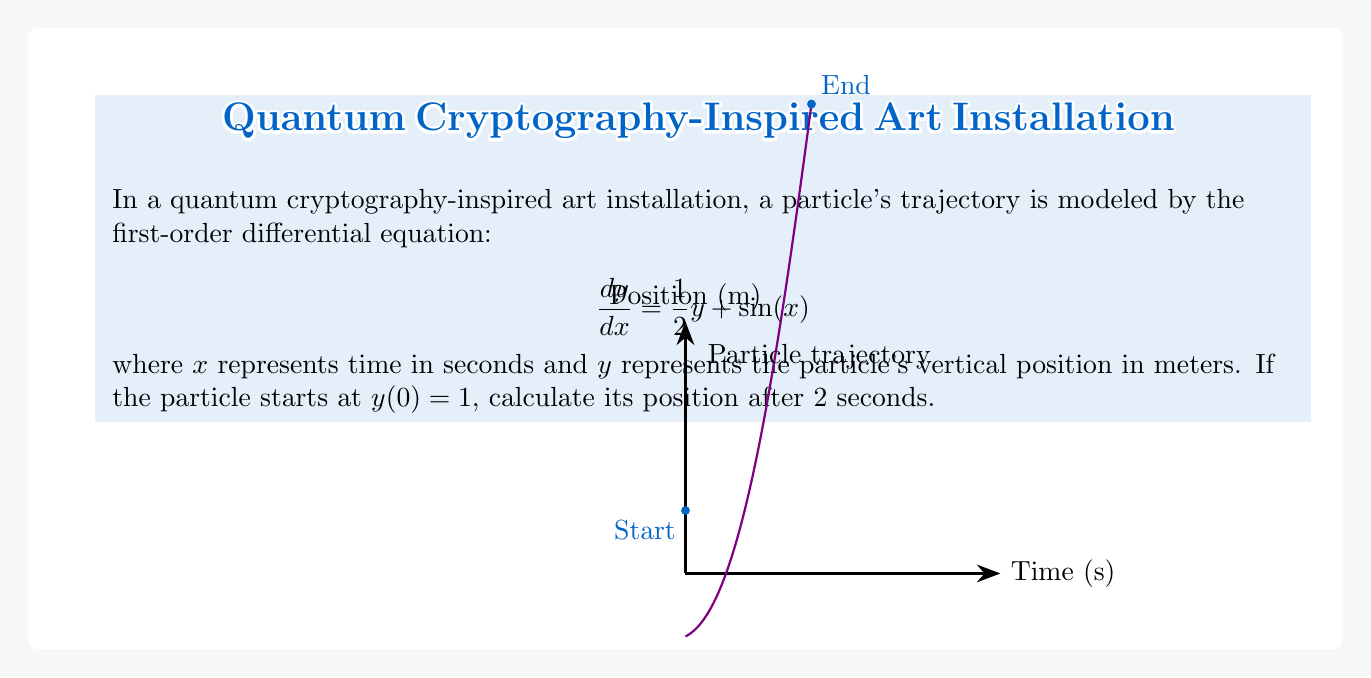Help me with this question. To solve this first-order differential equation, we'll use the integrating factor method:

1) The integrating factor is $\mu(x) = e^{\int \frac{1}{2} dx} = e^{\frac{1}{2}x}$

2) Multiply both sides of the equation by $\mu(x)$:
   $$e^{\frac{1}{2}x} \frac{dy}{dx} = \frac{1}{2}ye^{\frac{1}{2}x} + e^{\frac{1}{2}x}\sin(x)$$

3) The left side becomes $\frac{d}{dx}(ye^{\frac{1}{2}x})$, so we have:
   $$\frac{d}{dx}(ye^{\frac{1}{2}x}) = e^{\frac{1}{2}x}\sin(x)$$

4) Integrate both sides:
   $$ye^{\frac{1}{2}x} = \int e^{\frac{1}{2}x}\sin(x) dx$$

5) The integral on the right side can be solved using integration by parts:
   $$\int e^{\frac{1}{2}x}\sin(x) dx = e^{\frac{1}{2}x}(2\sin(x) - \cos(x)) + C$$

6) Therefore, the general solution is:
   $$y = e^{-\frac{1}{2}x}(e^{\frac{1}{2}x}(2\sin(x) - \cos(x)) + C)$$
   $$y = 2\sin(x) - \cos(x) + Ce^{-\frac{1}{2}x}$$

7) Use the initial condition $y(0) = 1$ to find $C$:
   $$1 = -1 + C$$
   $$C = 2$$

8) The particular solution is:
   $$y = 2\sin(x) - \cos(x) + 2e^{-\frac{1}{2}x}$$

9) Calculate $y(2)$:
   $$y(2) = 2\sin(2) - \cos(2) + 2e^{-1}$$
   $$y(2) \approx 2.850$$
Answer: $y(2) \approx 2.850$ meters 